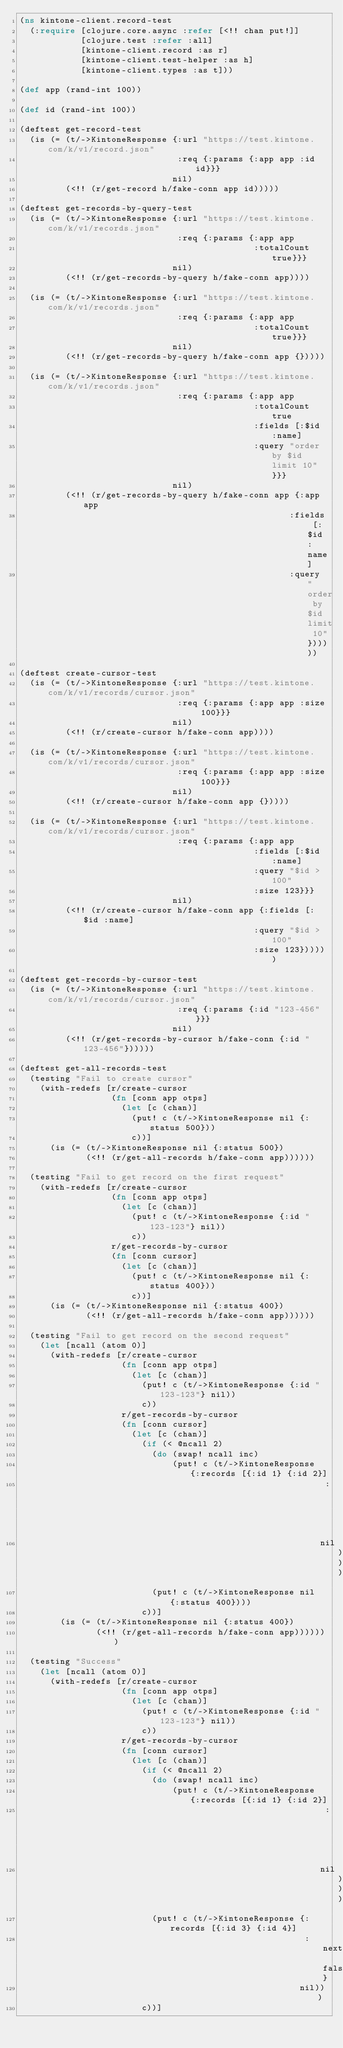Convert code to text. <code><loc_0><loc_0><loc_500><loc_500><_Clojure_>(ns kintone-client.record-test
  (:require [clojure.core.async :refer [<!! chan put!]]
            [clojure.test :refer :all]
            [kintone-client.record :as r]
            [kintone-client.test-helper :as h]
            [kintone-client.types :as t]))

(def app (rand-int 100))

(def id (rand-int 100))

(deftest get-record-test
  (is (= (t/->KintoneResponse {:url "https://test.kintone.com/k/v1/record.json"
                               :req {:params {:app app :id id}}}
                              nil)
         (<!! (r/get-record h/fake-conn app id)))))

(deftest get-records-by-query-test
  (is (= (t/->KintoneResponse {:url "https://test.kintone.com/k/v1/records.json"
                               :req {:params {:app app
                                              :totalCount true}}}
                              nil)
         (<!! (r/get-records-by-query h/fake-conn app))))

  (is (= (t/->KintoneResponse {:url "https://test.kintone.com/k/v1/records.json"
                               :req {:params {:app app
                                              :totalCount true}}}
                              nil)
         (<!! (r/get-records-by-query h/fake-conn app {}))))

  (is (= (t/->KintoneResponse {:url "https://test.kintone.com/k/v1/records.json"
                               :req {:params {:app app
                                              :totalCount true
                                              :fields [:$id :name]
                                              :query "order by $id limit 10"}}}
                              nil)
         (<!! (r/get-records-by-query h/fake-conn app {:app app
                                                     :fields [:$id :name]
                                                     :query "order by $id limit 10"})))))

(deftest create-cursor-test
  (is (= (t/->KintoneResponse {:url "https://test.kintone.com/k/v1/records/cursor.json"
                               :req {:params {:app app :size 100}}}
                              nil)
         (<!! (r/create-cursor h/fake-conn app))))

  (is (= (t/->KintoneResponse {:url "https://test.kintone.com/k/v1/records/cursor.json"
                               :req {:params {:app app :size 100}}}
                              nil)
         (<!! (r/create-cursor h/fake-conn app {}))))

  (is (= (t/->KintoneResponse {:url "https://test.kintone.com/k/v1/records/cursor.json"
                               :req {:params {:app app
                                              :fields [:$id :name]
                                              :query "$id > 100"
                                              :size 123}}}
                              nil)
         (<!! (r/create-cursor h/fake-conn app {:fields [:$id :name]
                                              :query "$id > 100"
                                              :size 123})))))

(deftest get-records-by-cursor-test
  (is (= (t/->KintoneResponse {:url "https://test.kintone.com/k/v1/records/cursor.json"
                               :req {:params {:id "123-456"}}}
                              nil)
         (<!! (r/get-records-by-cursor h/fake-conn {:id "123-456"})))))

(deftest get-all-records-test
  (testing "Fail to create cursor"
    (with-redefs [r/create-cursor
                  (fn [conn app otps]
                    (let [c (chan)]
                      (put! c (t/->KintoneResponse nil {:status 500}))
                      c))]
      (is (= (t/->KintoneResponse nil {:status 500})
             (<!! (r/get-all-records h/fake-conn app))))))

  (testing "Fail to get record on the first request"
    (with-redefs [r/create-cursor
                  (fn [conn app otps]
                    (let [c (chan)]
                      (put! c (t/->KintoneResponse {:id "123-123"} nil))
                      c))
                  r/get-records-by-cursor
                  (fn [conn cursor]
                    (let [c (chan)]
                      (put! c (t/->KintoneResponse nil {:status 400}))
                      c))]
      (is (= (t/->KintoneResponse nil {:status 400})
             (<!! (r/get-all-records h/fake-conn app))))))

  (testing "Fail to get record on the second request"
    (let [ncall (atom 0)]
      (with-redefs [r/create-cursor
                    (fn [conn app otps]
                      (let [c (chan)]
                        (put! c (t/->KintoneResponse {:id "123-123"} nil))
                        c))
                    r/get-records-by-cursor
                    (fn [conn cursor]
                      (let [c (chan)]
                        (if (< @ncall 2)
                          (do (swap! ncall inc)
                              (put! c (t/->KintoneResponse {:records [{:id 1} {:id 2}]
                                                            :next true}
                                                           nil)))
                          (put! c (t/->KintoneResponse nil {:status 400})))
                        c))]
        (is (= (t/->KintoneResponse nil {:status 400})
               (<!! (r/get-all-records h/fake-conn app)))))))

  (testing "Success"
    (let [ncall (atom 0)]
      (with-redefs [r/create-cursor
                    (fn [conn app otps]
                      (let [c (chan)]
                        (put! c (t/->KintoneResponse {:id "123-123"} nil))
                        c))
                    r/get-records-by-cursor
                    (fn [conn cursor]
                      (let [c (chan)]
                        (if (< @ncall 2)
                          (do (swap! ncall inc)
                              (put! c (t/->KintoneResponse {:records [{:id 1} {:id 2}]
                                                            :next true}
                                                           nil)))
                          (put! c (t/->KintoneResponse {:records [{:id 3} {:id 4}]
                                                        :next false}
                                                       nil)))
                        c))]</code> 